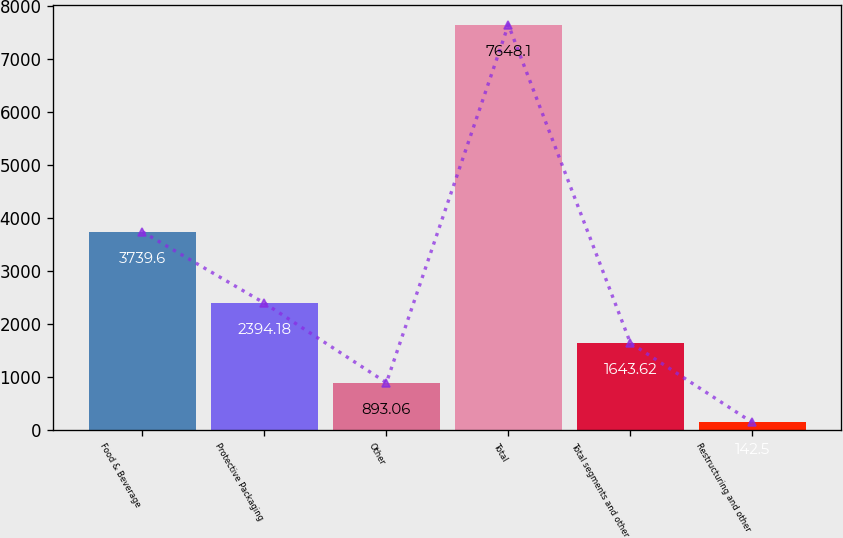Convert chart. <chart><loc_0><loc_0><loc_500><loc_500><bar_chart><fcel>Food & Beverage<fcel>Protective Packaging<fcel>Other<fcel>Total<fcel>Total segments and other<fcel>Restructuring and other<nl><fcel>3739.6<fcel>2394.18<fcel>893.06<fcel>7648.1<fcel>1643.62<fcel>142.5<nl></chart> 